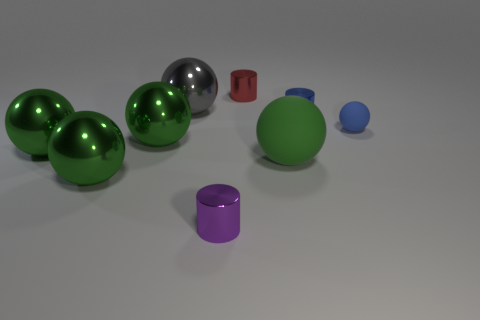Is the large rubber thing the same color as the small sphere?
Your answer should be compact. No. Is the number of small blue metal cylinders in front of the purple metal cylinder less than the number of blue rubber balls in front of the tiny blue rubber object?
Your answer should be compact. No. Does the cylinder that is right of the tiny red object have the same material as the green thing in front of the big rubber ball?
Your answer should be very brief. Yes. What is the shape of the large green rubber thing?
Keep it short and to the point. Sphere. Are there more small red shiny cylinders behind the small red metallic thing than green matte things that are behind the gray sphere?
Your answer should be compact. No. There is a tiny shiny thing right of the tiny red cylinder; is it the same shape as the small object that is in front of the large rubber object?
Your answer should be very brief. Yes. What number of other objects are there of the same size as the purple cylinder?
Your answer should be compact. 3. The purple metallic thing has what size?
Offer a very short reply. Small. Are there the same number of small purple shiny cylinders and purple metallic balls?
Keep it short and to the point. No. Do the blue thing to the right of the tiny blue cylinder and the small red object have the same material?
Your answer should be very brief. No. 